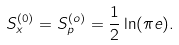Convert formula to latex. <formula><loc_0><loc_0><loc_500><loc_500>S _ { x } ^ { ( 0 ) } = S _ { p } ^ { ( o ) } = \frac { 1 } { 2 } \ln ( \pi e ) .</formula> 